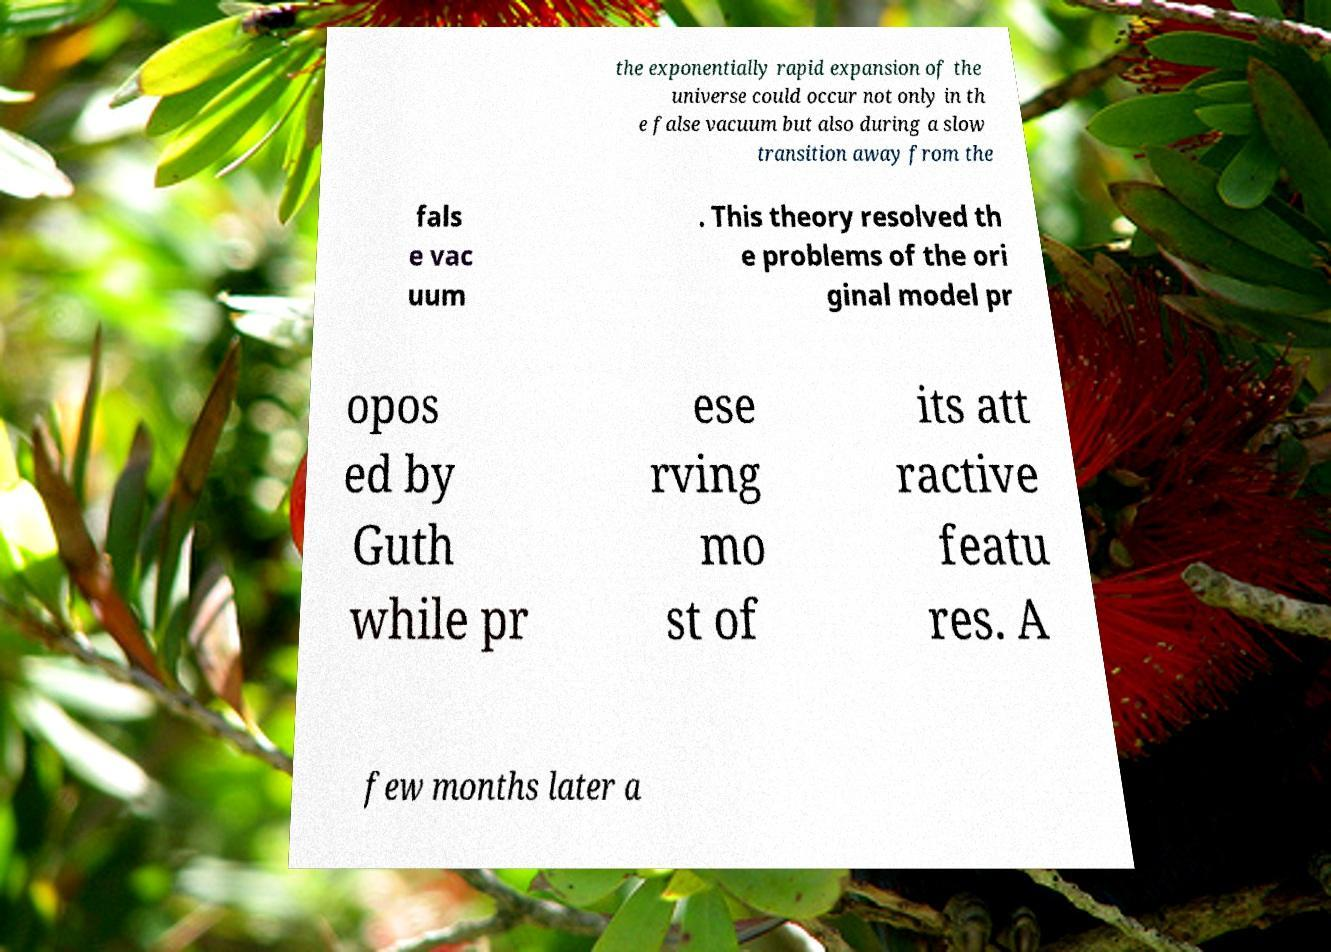Please read and relay the text visible in this image. What does it say? the exponentially rapid expansion of the universe could occur not only in th e false vacuum but also during a slow transition away from the fals e vac uum . This theory resolved th e problems of the ori ginal model pr opos ed by Guth while pr ese rving mo st of its att ractive featu res. A few months later a 